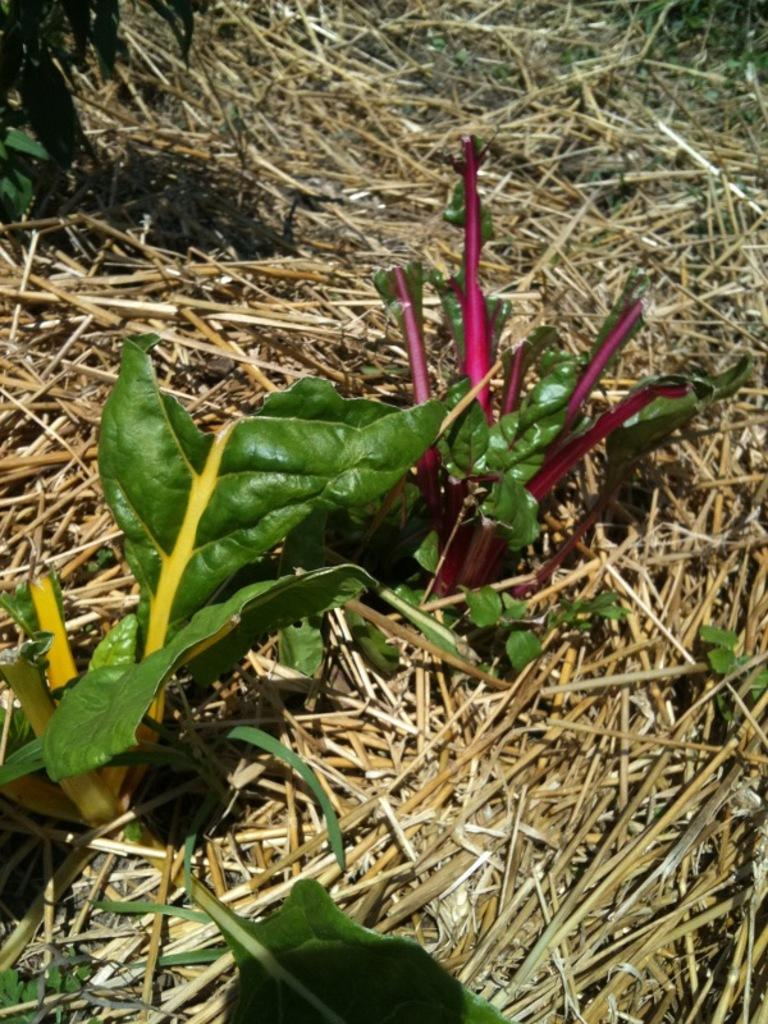What type of vegetation can be seen on the ground in the image? There are plants on the ground in the image. What is the condition of the grass on the ground in the image? There is dried grass on the ground in the image. What type of fang can be seen in the image? There is no fang present in the image; it features plants and dried grass. What type of frame is visible in the image? There is no frame present in the image. 